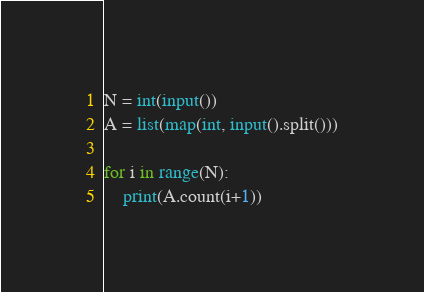<code> <loc_0><loc_0><loc_500><loc_500><_Python_>N = int(input())
A = list(map(int, input().split()))

for i in range(N):
    print(A.count(i+1))</code> 